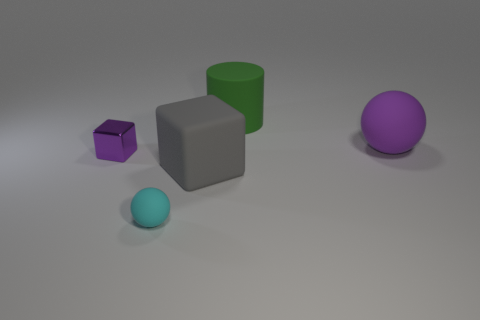Add 1 green rubber things. How many objects exist? 6 Subtract all cylinders. How many objects are left? 4 Add 5 tiny yellow matte cylinders. How many tiny yellow matte cylinders exist? 5 Subtract 0 purple cylinders. How many objects are left? 5 Subtract all cylinders. Subtract all big spheres. How many objects are left? 3 Add 5 big gray rubber blocks. How many big gray rubber blocks are left? 6 